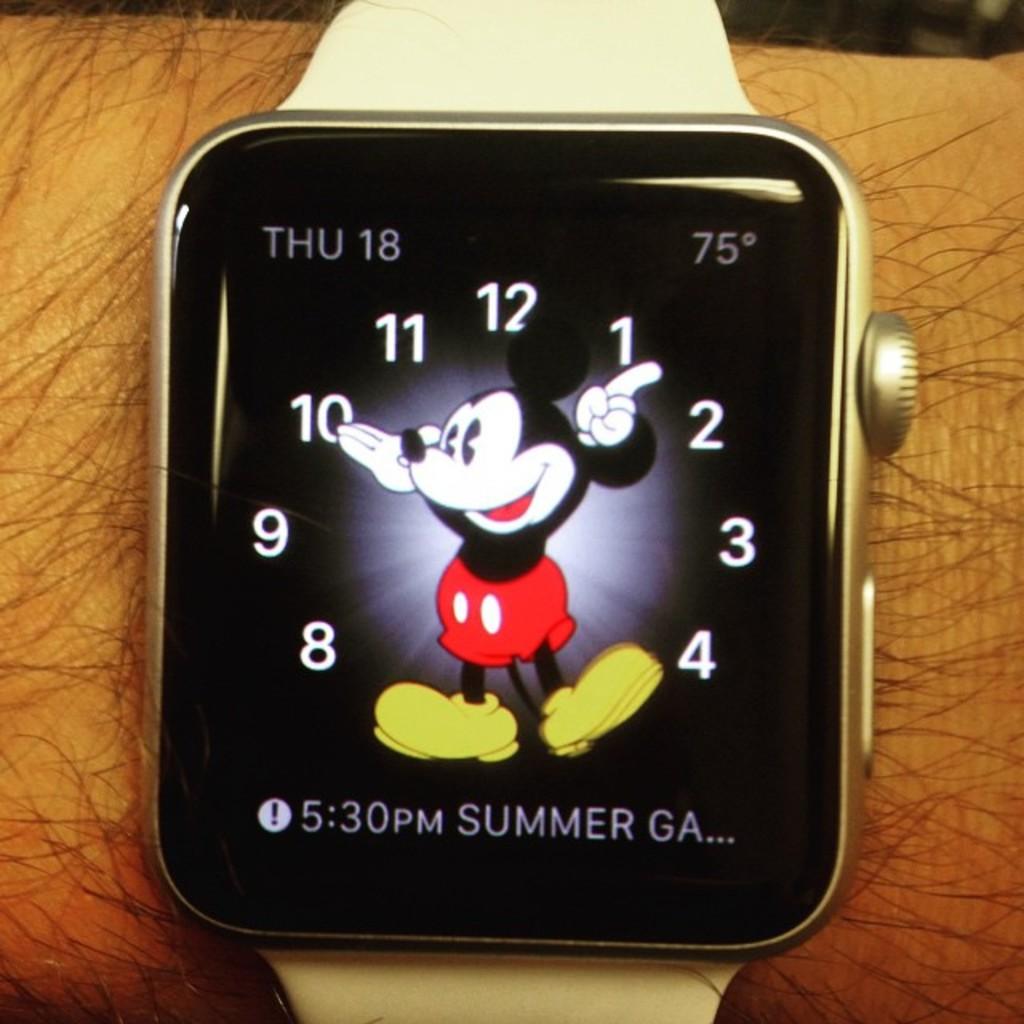What is the temperature on this watch?
Make the answer very short. 75. What american state is listed on the watch?
Offer a very short reply. Unanswerable. 